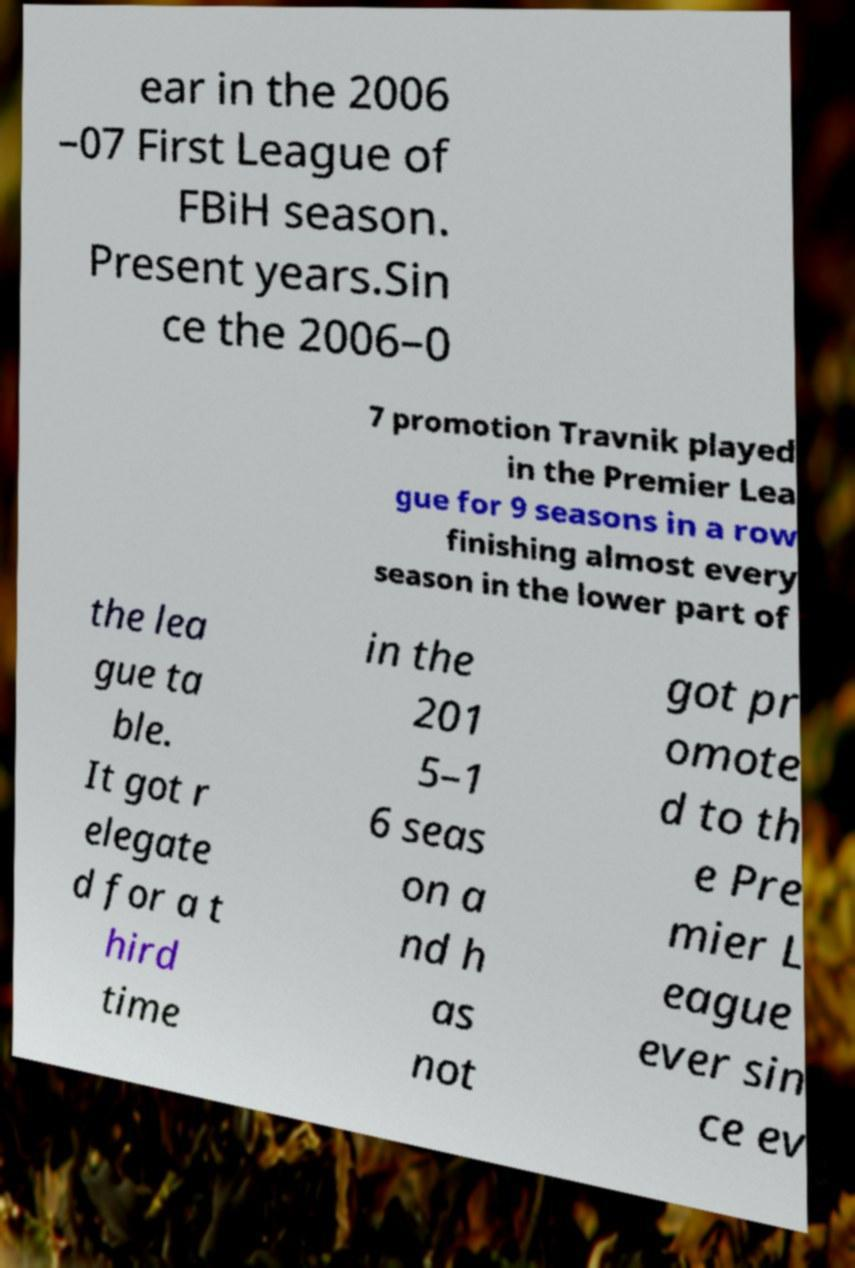What messages or text are displayed in this image? I need them in a readable, typed format. ear in the 2006 –07 First League of FBiH season. Present years.Sin ce the 2006–0 7 promotion Travnik played in the Premier Lea gue for 9 seasons in a row finishing almost every season in the lower part of the lea gue ta ble. It got r elegate d for a t hird time in the 201 5–1 6 seas on a nd h as not got pr omote d to th e Pre mier L eague ever sin ce ev 